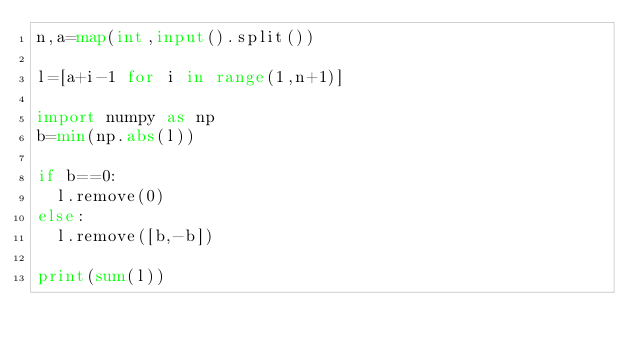<code> <loc_0><loc_0><loc_500><loc_500><_Python_>n,a=map(int,input().split())

l=[a+i-1 for i in range(1,n+1)]

import numpy as np
b=min(np.abs(l))

if b==0:
  l.remove(0)
else:
  l.remove([b,-b])
  
print(sum(l))</code> 